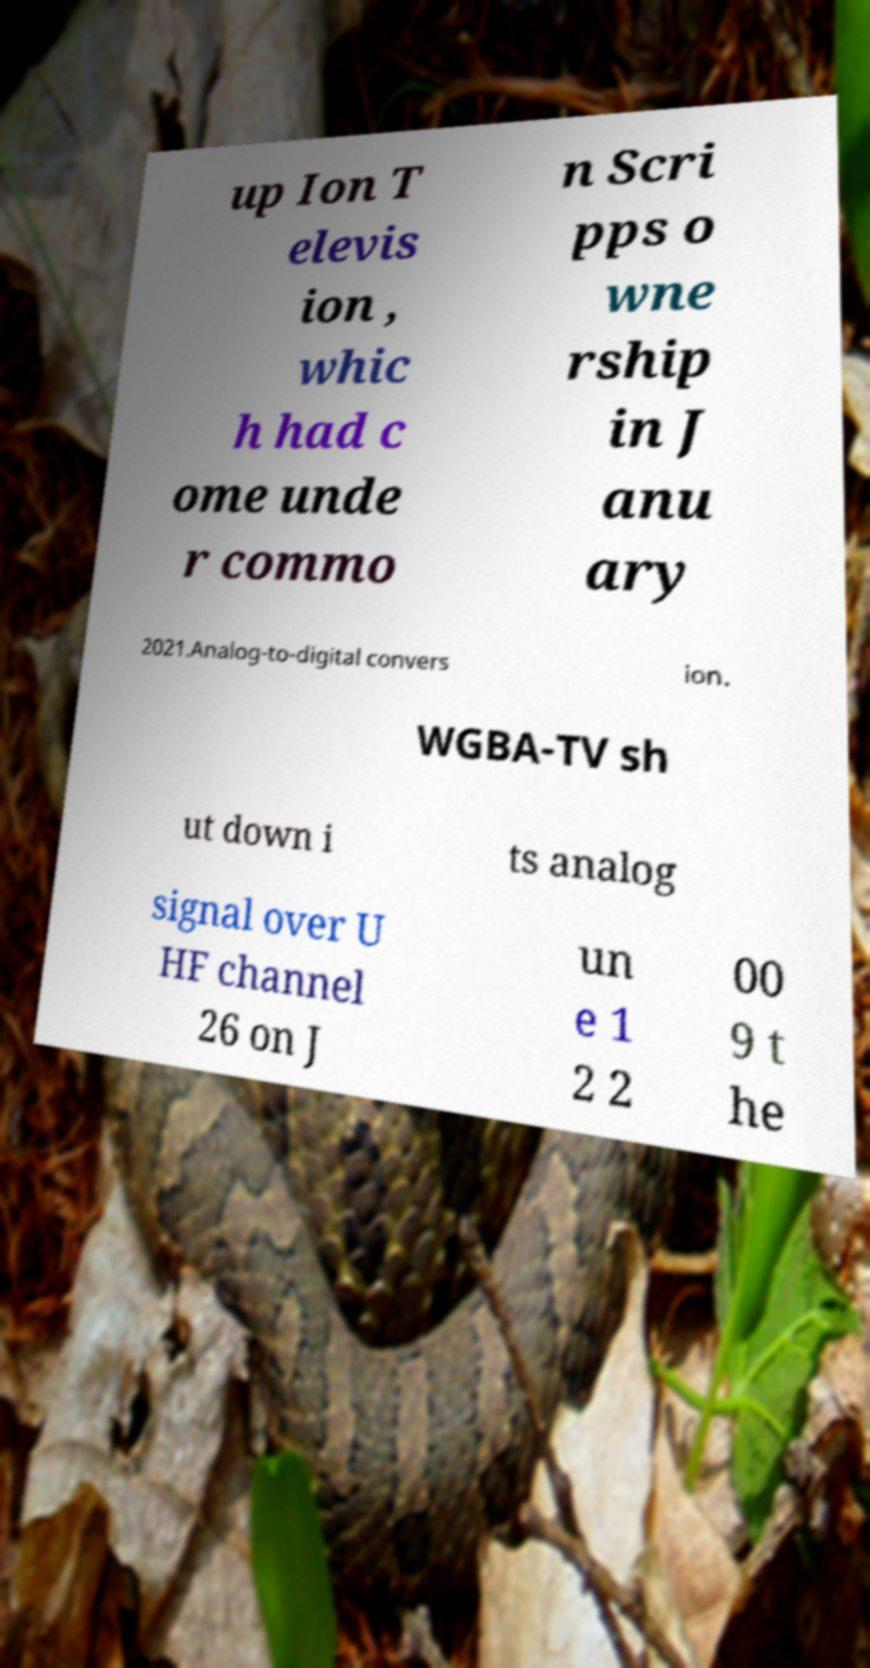Can you read and provide the text displayed in the image?This photo seems to have some interesting text. Can you extract and type it out for me? up Ion T elevis ion , whic h had c ome unde r commo n Scri pps o wne rship in J anu ary 2021.Analog-to-digital convers ion. WGBA-TV sh ut down i ts analog signal over U HF channel 26 on J un e 1 2 2 00 9 t he 